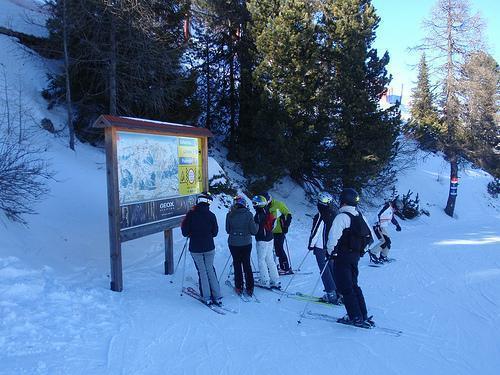How many people wears yellow jackets?
Give a very brief answer. 1. 